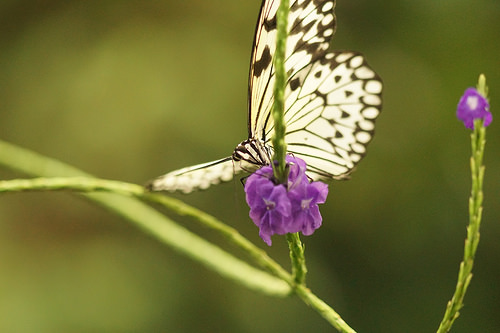<image>
Can you confirm if the butterfly is above the flower? Yes. The butterfly is positioned above the flower in the vertical space, higher up in the scene. 